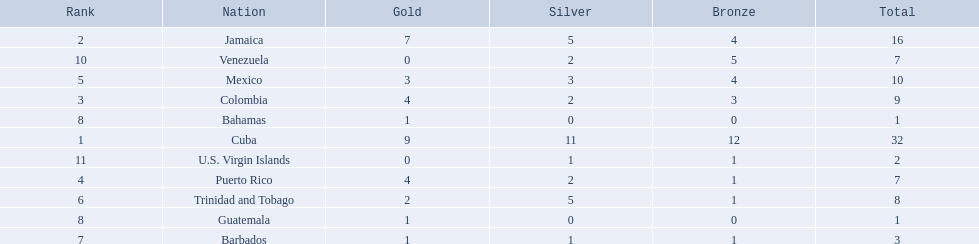Which teams have at exactly 4 gold medals? Colombia, Puerto Rico. Of those teams which has exactly 1 bronze medal? Puerto Rico. Write the full table. {'header': ['Rank', 'Nation', 'Gold', 'Silver', 'Bronze', 'Total'], 'rows': [['2', 'Jamaica', '7', '5', '4', '16'], ['10', 'Venezuela', '0', '2', '5', '7'], ['5', 'Mexico', '3', '3', '4', '10'], ['3', 'Colombia', '4', '2', '3', '9'], ['8', 'Bahamas', '1', '0', '0', '1'], ['1', 'Cuba', '9', '11', '12', '32'], ['11', 'U.S. Virgin Islands', '0', '1', '1', '2'], ['4', 'Puerto Rico', '4', '2', '1', '7'], ['6', 'Trinidad and Tobago', '2', '5', '1', '8'], ['8', 'Guatemala', '1', '0', '0', '1'], ['7', 'Barbados', '1', '1', '1', '3']]} 